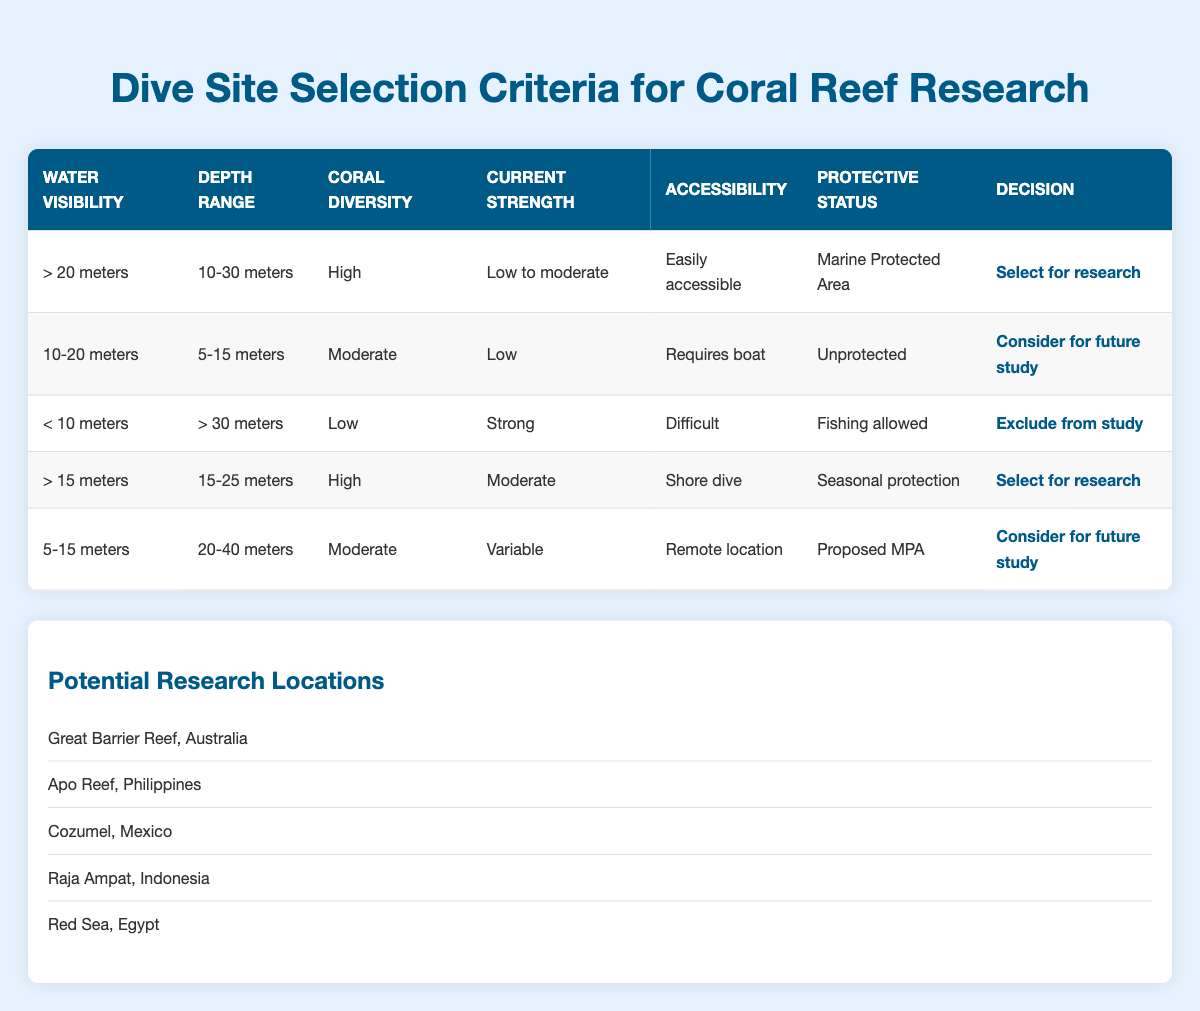What decision is made for a dive site with more than 20 meters of water visibility, 10-30 meters depth, high coral diversity, low to moderate current strength, easily accessible, and marine protected area status? The conditions for this dive site meet all the criteria for selecting it for research. Referring to the table, the matching rule states "Select for research" when all these factors are present.
Answer: Select for research How many dive sites are excluded from study based on the criteria provided? The table lists three different rules. Upon reviewing, only one rule has the decision "Exclude from study." Thus, there is one dive site excluded.
Answer: One Is it true that the dive site with less than 10 meters water visibility and strong current strength is considered for future study? Looking at the table, the conditions specified for the site with less than 10 meters visibility and strong current strength lead to the decision "Exclude from study," not "Consider for future study."
Answer: No What are the coral diversity ratings for dive sites that are selected for research? Two rows in the table correspond to the decision "Select for research," with coral diversity ratings of "High" for both cases. Thus, the coral diversity rating is consistently high for the sites selected for research.
Answer: High What is the depth range for dive sites that are considered for future study? By examining the table, there are two cases where the decision is "Consider for future study." The related depth ranges are 5-15 meters and 20-40 meters. Therefore, the depth ranges for future study include both.
Answer: 5-15 meters and 20-40 meters For sites that are easily accessible, what is the protective status? There is one site listed as "easily accessible," characterized by a protective status of "Marine Protected Area.” Thus, it ensures a better environment for research.
Answer: Marine Protected Area Which decision applies to a dive site with moderate current strength, depth range of 15-25 meters, and seasonal protection status? The conditions of moderate current strength and a depth range of 15-25 meters lead to the decision "Select for research" based on the data in the table.
Answer: Select for research What is the accessibility status of dive sites with medium coral diversity? The medium coral diversity has two related dive site entries with respective accessibility statuses as "Requires boat" and "Remote location." Hence, both of them indicate more challenging accessibility.
Answer: Requires boat and Remote location 